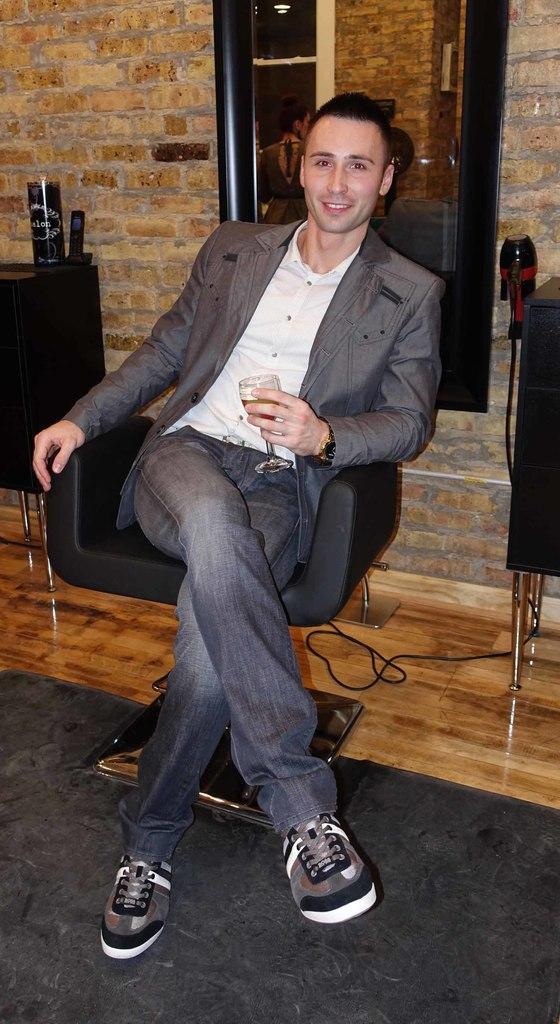Could you give a brief overview of what you see in this image? This image consists of a man who is sitting in a chair ,he wore grey color blazer white color shirt and black color pant. He has glass in his hand. He wore shoes. Beside him right side there is a hair dryer and left side there is some bottle. Behind him on the top there is a mirror ,in the bottom there is wire and carpet. 